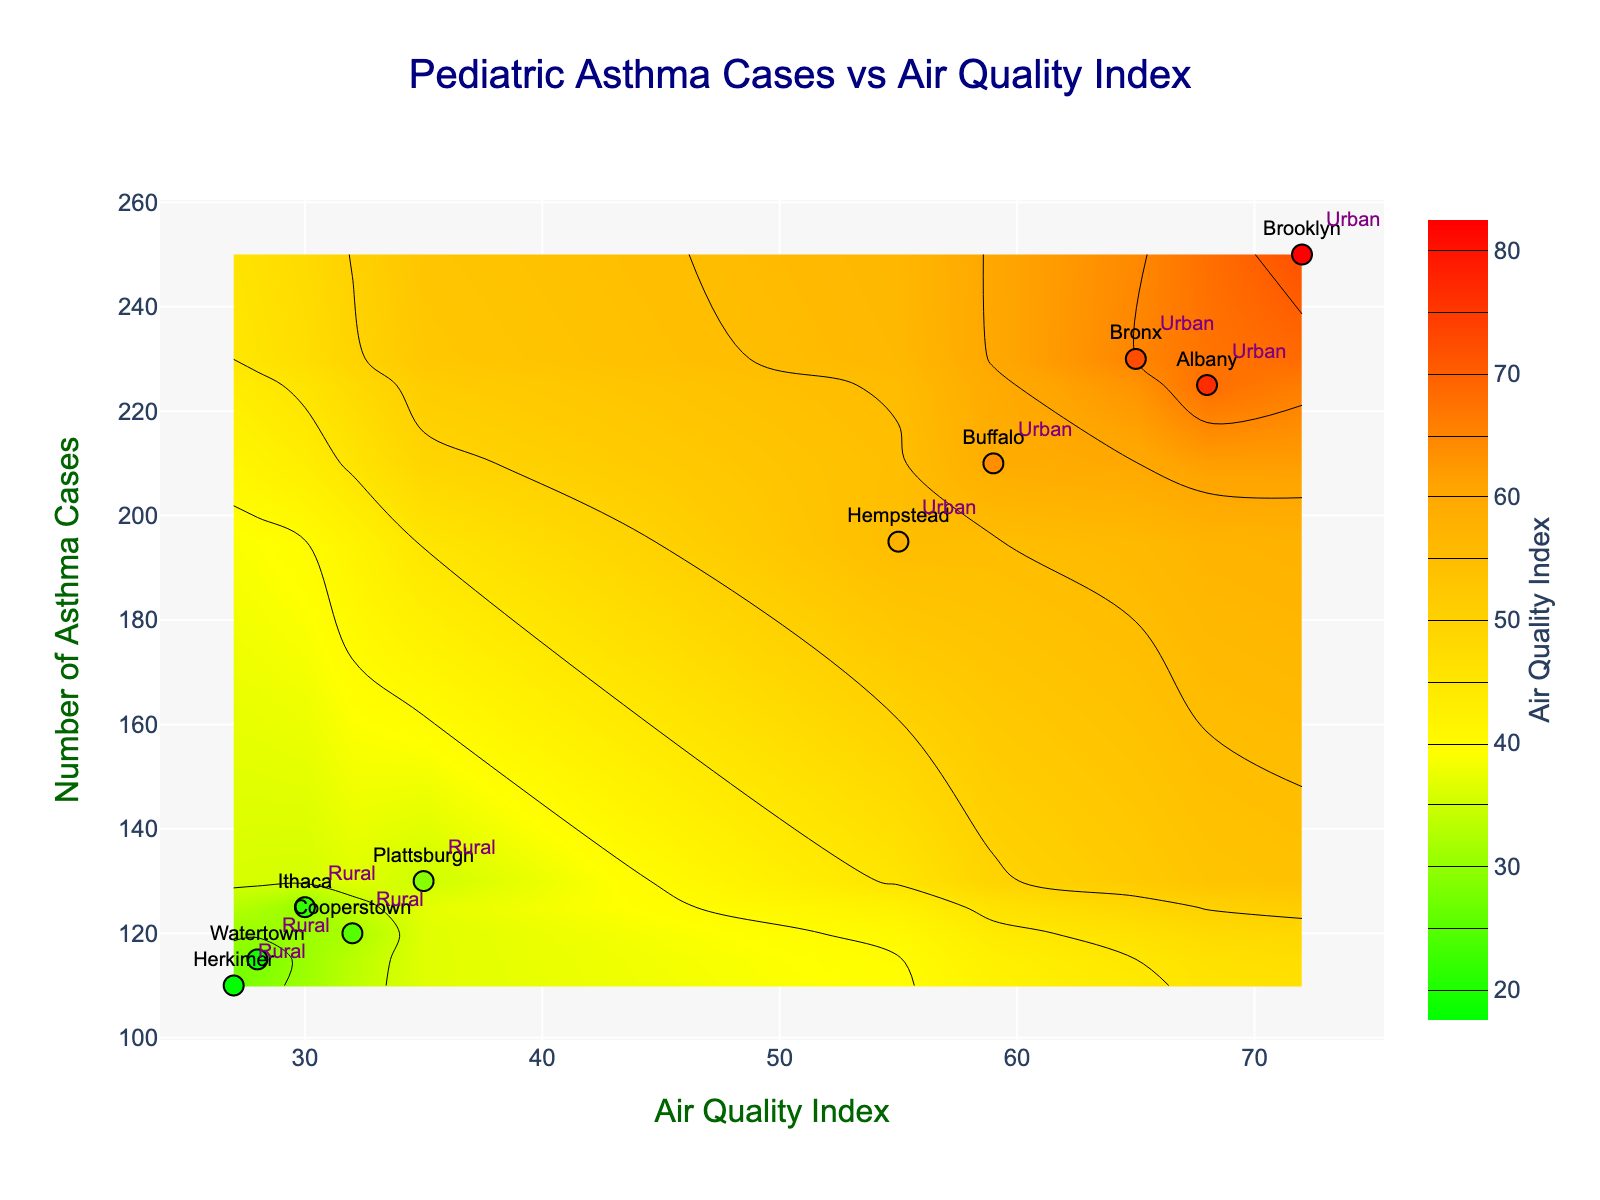What is the title of the plot? Look at the top of the plot to find the text that provides an overview of what the plot represents.
Answer: Pediatric Asthma Cases vs Air Quality Index How many data points are represented in the plot? Count the number of markers plotted on the figure. Each marker represents a data point.
Answer: 10 Which region has the highest Asthma Cases according to the plot? Locate the highest value on the 'Number of Asthma Cases' axis and check the corresponding region label.
Answer: Brooklyn What is the Air Quality Index for Ithaca? Locate Ithaca in the plot and read the value on the 'Air Quality Index' axis.
Answer: 30 Which area type, Urban or Rural, generally has higher Air Quality Index values? Observe the distribution of data points and their labels 'Urban' and 'Rural', and compare their positions on the 'Air Quality Index' axis.
Answer: Urban On average, do Urban areas have more or fewer Asthma Cases compared to Rural areas? Calculate the average number of Asthma Cases for Urban regions and compare it with Rural regions. Urban: (230+250+210+195+225)/5 = 222. Rural: (125+115+130+120+110)/5 = 120
Answer: More Which Urban area has the lowest Air Quality Index? Identify the data points labeled 'Urban' and find the one with the lowest value on the 'Air Quality Index' axis.
Answer: Hempstead How does the contour color change as the Air Quality Index increases? Observe the color gradient of the contour plot and its relation to increasing Air Quality Index values.
Answer: Changes from green to red What is the average Air Quality Index of all the regions? Calculate the mean of the Air Quality Index values for all regions. (65+72+59+55+68+30+28+35+32+27)/10 = 47.1
Answer: 47.1 Is there a correlation between Air Quality Index and Asthma Cases? Look at the general trend of data points, if higher Air Quality Index results in more Asthma Cases, it suggests a positive correlation.
Answer: Yes 